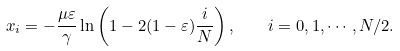<formula> <loc_0><loc_0><loc_500><loc_500>x _ { i } = - \frac { \mu \varepsilon } { \gamma } \ln \left ( 1 - 2 ( 1 - \varepsilon ) \frac { i } { N } \right ) , \quad i = 0 , 1 , \cdots , N / 2 .</formula> 